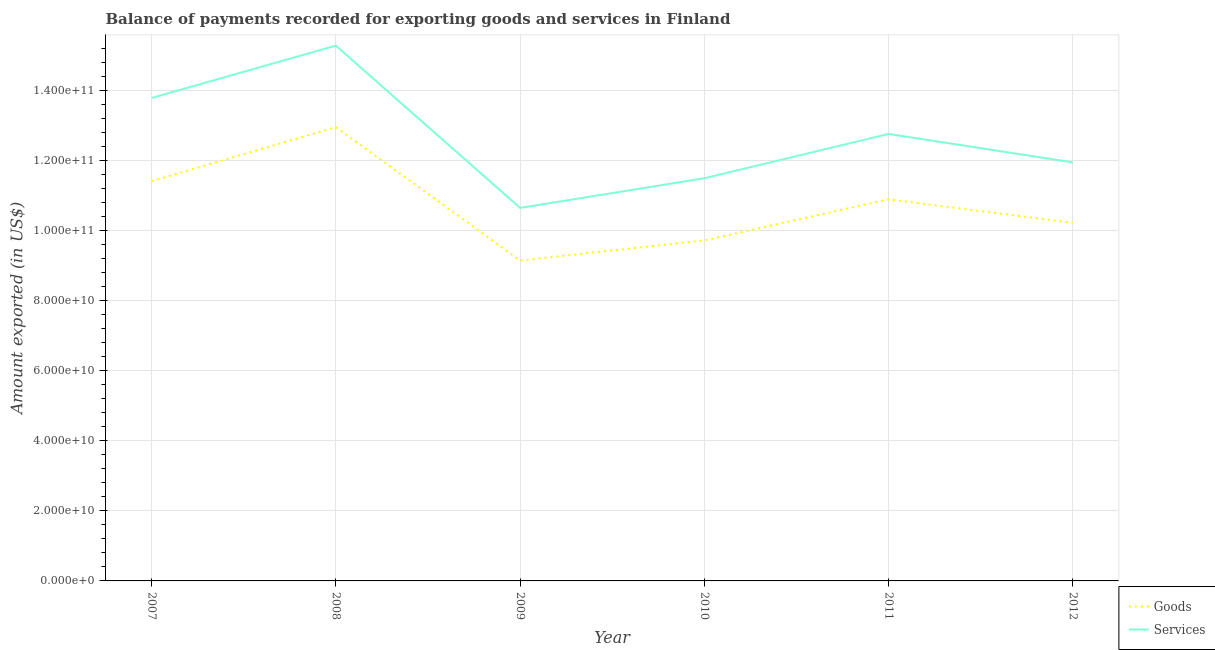How many different coloured lines are there?
Your answer should be compact. 2. Is the number of lines equal to the number of legend labels?
Your answer should be compact. Yes. What is the amount of services exported in 2011?
Provide a succinct answer. 1.28e+11. Across all years, what is the maximum amount of goods exported?
Your answer should be compact. 1.30e+11. Across all years, what is the minimum amount of goods exported?
Your answer should be very brief. 9.15e+1. In which year was the amount of services exported maximum?
Provide a short and direct response. 2008. In which year was the amount of services exported minimum?
Your answer should be very brief. 2009. What is the total amount of goods exported in the graph?
Your answer should be very brief. 6.44e+11. What is the difference between the amount of services exported in 2007 and that in 2009?
Give a very brief answer. 3.14e+1. What is the difference between the amount of services exported in 2008 and the amount of goods exported in 2009?
Your answer should be very brief. 6.14e+1. What is the average amount of services exported per year?
Keep it short and to the point. 1.27e+11. In the year 2010, what is the difference between the amount of services exported and amount of goods exported?
Make the answer very short. 1.77e+1. What is the ratio of the amount of goods exported in 2010 to that in 2011?
Your answer should be very brief. 0.89. What is the difference between the highest and the second highest amount of services exported?
Your answer should be compact. 1.49e+1. What is the difference between the highest and the lowest amount of services exported?
Provide a succinct answer. 4.63e+1. Is the amount of goods exported strictly less than the amount of services exported over the years?
Provide a succinct answer. Yes. How many lines are there?
Provide a succinct answer. 2. Are the values on the major ticks of Y-axis written in scientific E-notation?
Offer a terse response. Yes. Does the graph contain grids?
Give a very brief answer. Yes. Where does the legend appear in the graph?
Ensure brevity in your answer.  Bottom right. How are the legend labels stacked?
Give a very brief answer. Vertical. What is the title of the graph?
Offer a terse response. Balance of payments recorded for exporting goods and services in Finland. Does "Net National savings" appear as one of the legend labels in the graph?
Your answer should be very brief. No. What is the label or title of the Y-axis?
Keep it short and to the point. Amount exported (in US$). What is the Amount exported (in US$) in Goods in 2007?
Offer a very short reply. 1.14e+11. What is the Amount exported (in US$) of Services in 2007?
Ensure brevity in your answer.  1.38e+11. What is the Amount exported (in US$) in Goods in 2008?
Ensure brevity in your answer.  1.30e+11. What is the Amount exported (in US$) of Services in 2008?
Offer a very short reply. 1.53e+11. What is the Amount exported (in US$) of Goods in 2009?
Your response must be concise. 9.15e+1. What is the Amount exported (in US$) in Services in 2009?
Offer a very short reply. 1.07e+11. What is the Amount exported (in US$) in Goods in 2010?
Keep it short and to the point. 9.72e+1. What is the Amount exported (in US$) in Services in 2010?
Offer a terse response. 1.15e+11. What is the Amount exported (in US$) in Goods in 2011?
Ensure brevity in your answer.  1.09e+11. What is the Amount exported (in US$) of Services in 2011?
Keep it short and to the point. 1.28e+11. What is the Amount exported (in US$) in Goods in 2012?
Provide a succinct answer. 1.02e+11. What is the Amount exported (in US$) of Services in 2012?
Provide a short and direct response. 1.20e+11. Across all years, what is the maximum Amount exported (in US$) in Goods?
Your answer should be compact. 1.30e+11. Across all years, what is the maximum Amount exported (in US$) in Services?
Keep it short and to the point. 1.53e+11. Across all years, what is the minimum Amount exported (in US$) in Goods?
Your answer should be very brief. 9.15e+1. Across all years, what is the minimum Amount exported (in US$) in Services?
Give a very brief answer. 1.07e+11. What is the total Amount exported (in US$) in Goods in the graph?
Your answer should be compact. 6.44e+11. What is the total Amount exported (in US$) of Services in the graph?
Your response must be concise. 7.59e+11. What is the difference between the Amount exported (in US$) of Goods in 2007 and that in 2008?
Offer a terse response. -1.54e+1. What is the difference between the Amount exported (in US$) in Services in 2007 and that in 2008?
Provide a short and direct response. -1.49e+1. What is the difference between the Amount exported (in US$) of Goods in 2007 and that in 2009?
Provide a succinct answer. 2.27e+1. What is the difference between the Amount exported (in US$) in Services in 2007 and that in 2009?
Provide a short and direct response. 3.14e+1. What is the difference between the Amount exported (in US$) of Goods in 2007 and that in 2010?
Offer a terse response. 1.69e+1. What is the difference between the Amount exported (in US$) in Services in 2007 and that in 2010?
Your answer should be compact. 2.29e+1. What is the difference between the Amount exported (in US$) of Goods in 2007 and that in 2011?
Your answer should be compact. 5.19e+09. What is the difference between the Amount exported (in US$) of Services in 2007 and that in 2011?
Offer a terse response. 1.03e+1. What is the difference between the Amount exported (in US$) in Goods in 2007 and that in 2012?
Keep it short and to the point. 1.19e+1. What is the difference between the Amount exported (in US$) of Services in 2007 and that in 2012?
Ensure brevity in your answer.  1.84e+1. What is the difference between the Amount exported (in US$) in Goods in 2008 and that in 2009?
Keep it short and to the point. 3.81e+1. What is the difference between the Amount exported (in US$) in Services in 2008 and that in 2009?
Make the answer very short. 4.63e+1. What is the difference between the Amount exported (in US$) of Goods in 2008 and that in 2010?
Provide a succinct answer. 3.24e+1. What is the difference between the Amount exported (in US$) in Services in 2008 and that in 2010?
Offer a terse response. 3.79e+1. What is the difference between the Amount exported (in US$) of Goods in 2008 and that in 2011?
Your answer should be compact. 2.06e+1. What is the difference between the Amount exported (in US$) of Services in 2008 and that in 2011?
Offer a very short reply. 2.52e+1. What is the difference between the Amount exported (in US$) of Goods in 2008 and that in 2012?
Keep it short and to the point. 2.74e+1. What is the difference between the Amount exported (in US$) of Services in 2008 and that in 2012?
Offer a terse response. 3.33e+1. What is the difference between the Amount exported (in US$) in Goods in 2009 and that in 2010?
Provide a succinct answer. -5.74e+09. What is the difference between the Amount exported (in US$) in Services in 2009 and that in 2010?
Your answer should be very brief. -8.47e+09. What is the difference between the Amount exported (in US$) of Goods in 2009 and that in 2011?
Make the answer very short. -1.75e+1. What is the difference between the Amount exported (in US$) of Services in 2009 and that in 2011?
Offer a very short reply. -2.11e+1. What is the difference between the Amount exported (in US$) of Goods in 2009 and that in 2012?
Make the answer very short. -1.07e+1. What is the difference between the Amount exported (in US$) of Services in 2009 and that in 2012?
Provide a short and direct response. -1.30e+1. What is the difference between the Amount exported (in US$) in Goods in 2010 and that in 2011?
Offer a terse response. -1.17e+1. What is the difference between the Amount exported (in US$) in Services in 2010 and that in 2011?
Ensure brevity in your answer.  -1.27e+1. What is the difference between the Amount exported (in US$) in Goods in 2010 and that in 2012?
Offer a very short reply. -5.00e+09. What is the difference between the Amount exported (in US$) of Services in 2010 and that in 2012?
Offer a terse response. -4.53e+09. What is the difference between the Amount exported (in US$) in Goods in 2011 and that in 2012?
Provide a short and direct response. 6.73e+09. What is the difference between the Amount exported (in US$) in Services in 2011 and that in 2012?
Offer a very short reply. 8.12e+09. What is the difference between the Amount exported (in US$) in Goods in 2007 and the Amount exported (in US$) in Services in 2008?
Give a very brief answer. -3.87e+1. What is the difference between the Amount exported (in US$) in Goods in 2007 and the Amount exported (in US$) in Services in 2009?
Provide a succinct answer. 7.64e+09. What is the difference between the Amount exported (in US$) in Goods in 2007 and the Amount exported (in US$) in Services in 2010?
Provide a succinct answer. -8.27e+08. What is the difference between the Amount exported (in US$) of Goods in 2007 and the Amount exported (in US$) of Services in 2011?
Provide a succinct answer. -1.35e+1. What is the difference between the Amount exported (in US$) of Goods in 2007 and the Amount exported (in US$) of Services in 2012?
Give a very brief answer. -5.36e+09. What is the difference between the Amount exported (in US$) in Goods in 2008 and the Amount exported (in US$) in Services in 2009?
Give a very brief answer. 2.31e+1. What is the difference between the Amount exported (in US$) of Goods in 2008 and the Amount exported (in US$) of Services in 2010?
Your answer should be compact. 1.46e+1. What is the difference between the Amount exported (in US$) in Goods in 2008 and the Amount exported (in US$) in Services in 2011?
Offer a terse response. 1.96e+09. What is the difference between the Amount exported (in US$) of Goods in 2008 and the Amount exported (in US$) of Services in 2012?
Your response must be concise. 1.01e+1. What is the difference between the Amount exported (in US$) of Goods in 2009 and the Amount exported (in US$) of Services in 2010?
Provide a succinct answer. -2.35e+1. What is the difference between the Amount exported (in US$) in Goods in 2009 and the Amount exported (in US$) in Services in 2011?
Give a very brief answer. -3.61e+1. What is the difference between the Amount exported (in US$) in Goods in 2009 and the Amount exported (in US$) in Services in 2012?
Provide a short and direct response. -2.80e+1. What is the difference between the Amount exported (in US$) of Goods in 2010 and the Amount exported (in US$) of Services in 2011?
Offer a terse response. -3.04e+1. What is the difference between the Amount exported (in US$) in Goods in 2010 and the Amount exported (in US$) in Services in 2012?
Offer a terse response. -2.23e+1. What is the difference between the Amount exported (in US$) of Goods in 2011 and the Amount exported (in US$) of Services in 2012?
Your response must be concise. -1.06e+1. What is the average Amount exported (in US$) of Goods per year?
Make the answer very short. 1.07e+11. What is the average Amount exported (in US$) in Services per year?
Your response must be concise. 1.27e+11. In the year 2007, what is the difference between the Amount exported (in US$) of Goods and Amount exported (in US$) of Services?
Keep it short and to the point. -2.38e+1. In the year 2008, what is the difference between the Amount exported (in US$) in Goods and Amount exported (in US$) in Services?
Provide a short and direct response. -2.33e+1. In the year 2009, what is the difference between the Amount exported (in US$) in Goods and Amount exported (in US$) in Services?
Your answer should be compact. -1.50e+1. In the year 2010, what is the difference between the Amount exported (in US$) of Goods and Amount exported (in US$) of Services?
Offer a very short reply. -1.77e+1. In the year 2011, what is the difference between the Amount exported (in US$) in Goods and Amount exported (in US$) in Services?
Give a very brief answer. -1.87e+1. In the year 2012, what is the difference between the Amount exported (in US$) of Goods and Amount exported (in US$) of Services?
Make the answer very short. -1.73e+1. What is the ratio of the Amount exported (in US$) in Goods in 2007 to that in 2008?
Your answer should be very brief. 0.88. What is the ratio of the Amount exported (in US$) of Services in 2007 to that in 2008?
Offer a very short reply. 0.9. What is the ratio of the Amount exported (in US$) in Goods in 2007 to that in 2009?
Make the answer very short. 1.25. What is the ratio of the Amount exported (in US$) of Services in 2007 to that in 2009?
Your answer should be very brief. 1.29. What is the ratio of the Amount exported (in US$) in Goods in 2007 to that in 2010?
Offer a very short reply. 1.17. What is the ratio of the Amount exported (in US$) of Services in 2007 to that in 2010?
Offer a terse response. 1.2. What is the ratio of the Amount exported (in US$) in Goods in 2007 to that in 2011?
Make the answer very short. 1.05. What is the ratio of the Amount exported (in US$) of Services in 2007 to that in 2011?
Provide a short and direct response. 1.08. What is the ratio of the Amount exported (in US$) of Goods in 2007 to that in 2012?
Your answer should be very brief. 1.12. What is the ratio of the Amount exported (in US$) in Services in 2007 to that in 2012?
Make the answer very short. 1.15. What is the ratio of the Amount exported (in US$) of Goods in 2008 to that in 2009?
Keep it short and to the point. 1.42. What is the ratio of the Amount exported (in US$) of Services in 2008 to that in 2009?
Ensure brevity in your answer.  1.44. What is the ratio of the Amount exported (in US$) in Goods in 2008 to that in 2010?
Your response must be concise. 1.33. What is the ratio of the Amount exported (in US$) in Services in 2008 to that in 2010?
Make the answer very short. 1.33. What is the ratio of the Amount exported (in US$) in Goods in 2008 to that in 2011?
Offer a terse response. 1.19. What is the ratio of the Amount exported (in US$) of Services in 2008 to that in 2011?
Your response must be concise. 1.2. What is the ratio of the Amount exported (in US$) in Goods in 2008 to that in 2012?
Your answer should be very brief. 1.27. What is the ratio of the Amount exported (in US$) in Services in 2008 to that in 2012?
Keep it short and to the point. 1.28. What is the ratio of the Amount exported (in US$) in Goods in 2009 to that in 2010?
Give a very brief answer. 0.94. What is the ratio of the Amount exported (in US$) of Services in 2009 to that in 2010?
Your response must be concise. 0.93. What is the ratio of the Amount exported (in US$) of Goods in 2009 to that in 2011?
Your answer should be compact. 0.84. What is the ratio of the Amount exported (in US$) in Services in 2009 to that in 2011?
Your answer should be very brief. 0.83. What is the ratio of the Amount exported (in US$) of Goods in 2009 to that in 2012?
Provide a short and direct response. 0.9. What is the ratio of the Amount exported (in US$) in Services in 2009 to that in 2012?
Your answer should be compact. 0.89. What is the ratio of the Amount exported (in US$) of Goods in 2010 to that in 2011?
Offer a very short reply. 0.89. What is the ratio of the Amount exported (in US$) of Services in 2010 to that in 2011?
Your answer should be compact. 0.9. What is the ratio of the Amount exported (in US$) in Goods in 2010 to that in 2012?
Offer a terse response. 0.95. What is the ratio of the Amount exported (in US$) of Services in 2010 to that in 2012?
Provide a succinct answer. 0.96. What is the ratio of the Amount exported (in US$) in Goods in 2011 to that in 2012?
Keep it short and to the point. 1.07. What is the ratio of the Amount exported (in US$) in Services in 2011 to that in 2012?
Give a very brief answer. 1.07. What is the difference between the highest and the second highest Amount exported (in US$) of Goods?
Make the answer very short. 1.54e+1. What is the difference between the highest and the second highest Amount exported (in US$) in Services?
Your response must be concise. 1.49e+1. What is the difference between the highest and the lowest Amount exported (in US$) in Goods?
Your answer should be very brief. 3.81e+1. What is the difference between the highest and the lowest Amount exported (in US$) in Services?
Your answer should be very brief. 4.63e+1. 